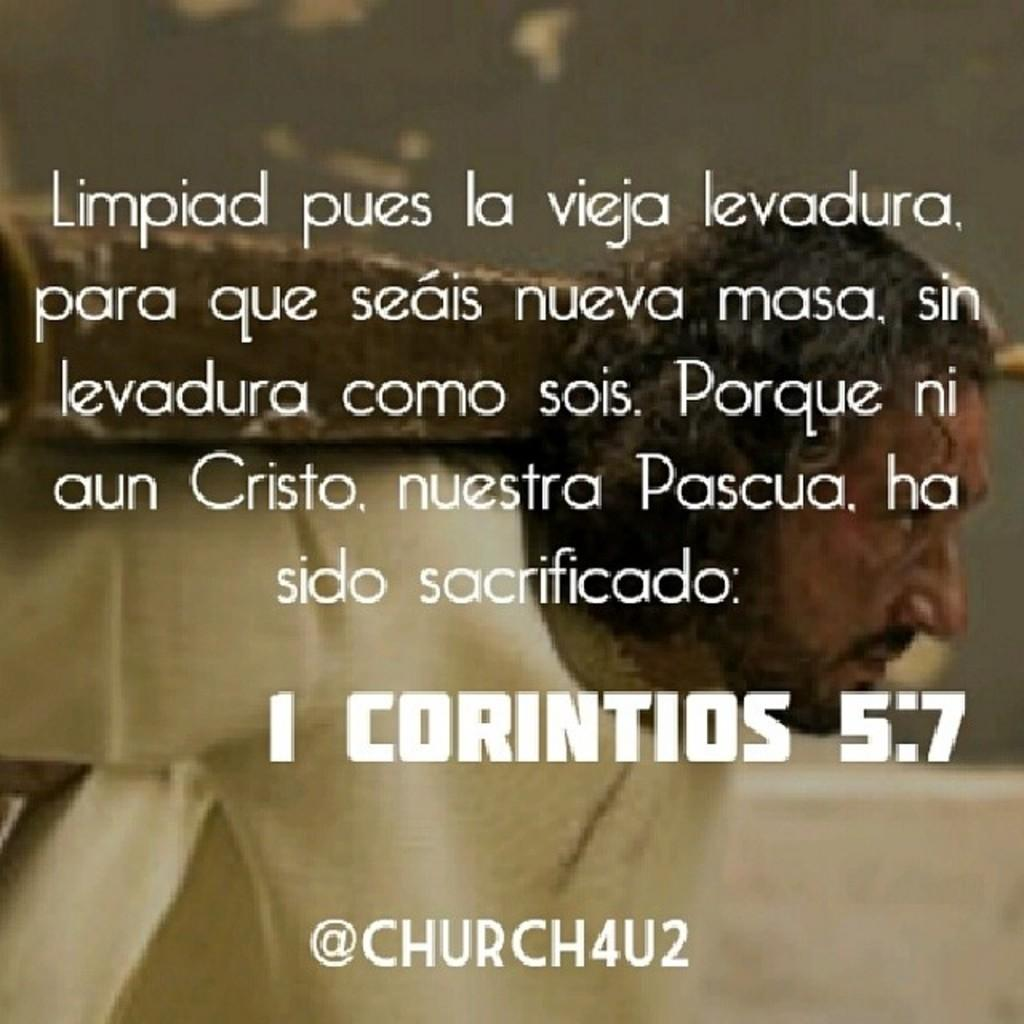What can be seen in the foreground of the image? There is some text in the foreground of the image. What is visible in the background of the image? There is a person in the background of the image. What is the person doing in the image? The person is carrying something. What type of wheel can be seen in the image? There is no wheel present in the image. Is there a turkey visible in the image? No, there is no turkey present in the image. 